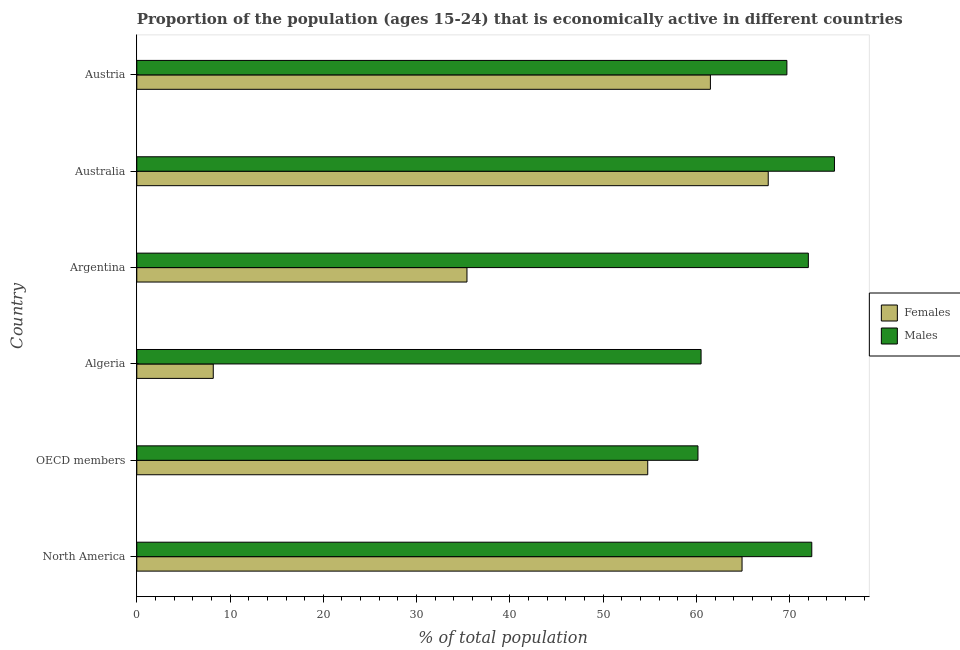How many different coloured bars are there?
Provide a succinct answer. 2. How many groups of bars are there?
Your answer should be very brief. 6. Are the number of bars per tick equal to the number of legend labels?
Provide a succinct answer. Yes. How many bars are there on the 5th tick from the bottom?
Provide a short and direct response. 2. What is the label of the 6th group of bars from the top?
Make the answer very short. North America. What is the percentage of economically active female population in OECD members?
Provide a short and direct response. 54.78. Across all countries, what is the maximum percentage of economically active male population?
Offer a very short reply. 74.8. Across all countries, what is the minimum percentage of economically active female population?
Give a very brief answer. 8.2. In which country was the percentage of economically active female population maximum?
Offer a very short reply. Australia. What is the total percentage of economically active male population in the graph?
Keep it short and to the point. 409.54. What is the difference between the percentage of economically active female population in Algeria and that in Austria?
Your answer should be compact. -53.3. What is the difference between the percentage of economically active male population in Australia and the percentage of economically active female population in OECD members?
Your answer should be compact. 20.02. What is the average percentage of economically active male population per country?
Keep it short and to the point. 68.26. What is the difference between the percentage of economically active male population and percentage of economically active female population in North America?
Ensure brevity in your answer.  7.48. What is the ratio of the percentage of economically active female population in Austria to that in North America?
Keep it short and to the point. 0.95. Is the difference between the percentage of economically active male population in Argentina and North America greater than the difference between the percentage of economically active female population in Argentina and North America?
Keep it short and to the point. Yes. What is the difference between the highest and the second highest percentage of economically active male population?
Provide a succinct answer. 2.43. What is the difference between the highest and the lowest percentage of economically active male population?
Your answer should be very brief. 14.63. Is the sum of the percentage of economically active male population in Algeria and OECD members greater than the maximum percentage of economically active female population across all countries?
Make the answer very short. Yes. What does the 1st bar from the top in Argentina represents?
Give a very brief answer. Males. What does the 1st bar from the bottom in North America represents?
Your response must be concise. Females. How many bars are there?
Keep it short and to the point. 12. Are all the bars in the graph horizontal?
Offer a terse response. Yes. Does the graph contain any zero values?
Offer a terse response. No. Does the graph contain grids?
Your answer should be compact. No. What is the title of the graph?
Provide a succinct answer. Proportion of the population (ages 15-24) that is economically active in different countries. What is the label or title of the X-axis?
Your answer should be very brief. % of total population. What is the % of total population of Females in North America?
Your response must be concise. 64.89. What is the % of total population of Males in North America?
Make the answer very short. 72.37. What is the % of total population of Females in OECD members?
Your answer should be compact. 54.78. What is the % of total population of Males in OECD members?
Provide a succinct answer. 60.17. What is the % of total population of Females in Algeria?
Your answer should be compact. 8.2. What is the % of total population in Males in Algeria?
Keep it short and to the point. 60.5. What is the % of total population in Females in Argentina?
Make the answer very short. 35.4. What is the % of total population of Females in Australia?
Ensure brevity in your answer.  67.7. What is the % of total population of Males in Australia?
Provide a succinct answer. 74.8. What is the % of total population of Females in Austria?
Your response must be concise. 61.5. What is the % of total population of Males in Austria?
Offer a terse response. 69.7. Across all countries, what is the maximum % of total population in Females?
Make the answer very short. 67.7. Across all countries, what is the maximum % of total population of Males?
Your answer should be compact. 74.8. Across all countries, what is the minimum % of total population of Females?
Your answer should be compact. 8.2. Across all countries, what is the minimum % of total population in Males?
Give a very brief answer. 60.17. What is the total % of total population in Females in the graph?
Provide a succinct answer. 292.47. What is the total % of total population in Males in the graph?
Offer a very short reply. 409.54. What is the difference between the % of total population of Females in North America and that in OECD members?
Ensure brevity in your answer.  10.11. What is the difference between the % of total population of Males in North America and that in OECD members?
Offer a terse response. 12.2. What is the difference between the % of total population in Females in North America and that in Algeria?
Give a very brief answer. 56.69. What is the difference between the % of total population in Males in North America and that in Algeria?
Ensure brevity in your answer.  11.87. What is the difference between the % of total population in Females in North America and that in Argentina?
Give a very brief answer. 29.49. What is the difference between the % of total population in Males in North America and that in Argentina?
Make the answer very short. 0.37. What is the difference between the % of total population of Females in North America and that in Australia?
Your answer should be compact. -2.81. What is the difference between the % of total population of Males in North America and that in Australia?
Your answer should be very brief. -2.43. What is the difference between the % of total population of Females in North America and that in Austria?
Your response must be concise. 3.39. What is the difference between the % of total population of Males in North America and that in Austria?
Provide a short and direct response. 2.67. What is the difference between the % of total population of Females in OECD members and that in Algeria?
Give a very brief answer. 46.58. What is the difference between the % of total population in Males in OECD members and that in Algeria?
Provide a succinct answer. -0.33. What is the difference between the % of total population of Females in OECD members and that in Argentina?
Ensure brevity in your answer.  19.38. What is the difference between the % of total population in Males in OECD members and that in Argentina?
Your answer should be very brief. -11.83. What is the difference between the % of total population of Females in OECD members and that in Australia?
Your answer should be very brief. -12.92. What is the difference between the % of total population in Males in OECD members and that in Australia?
Provide a short and direct response. -14.63. What is the difference between the % of total population in Females in OECD members and that in Austria?
Provide a succinct answer. -6.72. What is the difference between the % of total population of Males in OECD members and that in Austria?
Provide a short and direct response. -9.53. What is the difference between the % of total population in Females in Algeria and that in Argentina?
Your response must be concise. -27.2. What is the difference between the % of total population in Males in Algeria and that in Argentina?
Your response must be concise. -11.5. What is the difference between the % of total population in Females in Algeria and that in Australia?
Keep it short and to the point. -59.5. What is the difference between the % of total population in Males in Algeria and that in Australia?
Your response must be concise. -14.3. What is the difference between the % of total population in Females in Algeria and that in Austria?
Your answer should be very brief. -53.3. What is the difference between the % of total population in Males in Algeria and that in Austria?
Provide a short and direct response. -9.2. What is the difference between the % of total population in Females in Argentina and that in Australia?
Your response must be concise. -32.3. What is the difference between the % of total population of Males in Argentina and that in Australia?
Make the answer very short. -2.8. What is the difference between the % of total population of Females in Argentina and that in Austria?
Keep it short and to the point. -26.1. What is the difference between the % of total population of Males in Argentina and that in Austria?
Make the answer very short. 2.3. What is the difference between the % of total population in Females in North America and the % of total population in Males in OECD members?
Give a very brief answer. 4.73. What is the difference between the % of total population of Females in North America and the % of total population of Males in Algeria?
Your answer should be compact. 4.39. What is the difference between the % of total population of Females in North America and the % of total population of Males in Argentina?
Give a very brief answer. -7.11. What is the difference between the % of total population in Females in North America and the % of total population in Males in Australia?
Offer a terse response. -9.91. What is the difference between the % of total population of Females in North America and the % of total population of Males in Austria?
Provide a short and direct response. -4.81. What is the difference between the % of total population of Females in OECD members and the % of total population of Males in Algeria?
Ensure brevity in your answer.  -5.72. What is the difference between the % of total population in Females in OECD members and the % of total population in Males in Argentina?
Your answer should be very brief. -17.22. What is the difference between the % of total population of Females in OECD members and the % of total population of Males in Australia?
Keep it short and to the point. -20.02. What is the difference between the % of total population of Females in OECD members and the % of total population of Males in Austria?
Ensure brevity in your answer.  -14.92. What is the difference between the % of total population of Females in Algeria and the % of total population of Males in Argentina?
Your response must be concise. -63.8. What is the difference between the % of total population of Females in Algeria and the % of total population of Males in Australia?
Offer a very short reply. -66.6. What is the difference between the % of total population in Females in Algeria and the % of total population in Males in Austria?
Keep it short and to the point. -61.5. What is the difference between the % of total population in Females in Argentina and the % of total population in Males in Australia?
Ensure brevity in your answer.  -39.4. What is the difference between the % of total population of Females in Argentina and the % of total population of Males in Austria?
Offer a terse response. -34.3. What is the difference between the % of total population in Females in Australia and the % of total population in Males in Austria?
Provide a short and direct response. -2. What is the average % of total population in Females per country?
Offer a terse response. 48.75. What is the average % of total population of Males per country?
Your answer should be very brief. 68.26. What is the difference between the % of total population of Females and % of total population of Males in North America?
Your answer should be compact. -7.48. What is the difference between the % of total population of Females and % of total population of Males in OECD members?
Provide a short and direct response. -5.39. What is the difference between the % of total population in Females and % of total population in Males in Algeria?
Your answer should be very brief. -52.3. What is the difference between the % of total population of Females and % of total population of Males in Argentina?
Offer a very short reply. -36.6. What is the difference between the % of total population of Females and % of total population of Males in Australia?
Provide a succinct answer. -7.1. What is the ratio of the % of total population of Females in North America to that in OECD members?
Give a very brief answer. 1.18. What is the ratio of the % of total population in Males in North America to that in OECD members?
Your response must be concise. 1.2. What is the ratio of the % of total population in Females in North America to that in Algeria?
Ensure brevity in your answer.  7.91. What is the ratio of the % of total population of Males in North America to that in Algeria?
Provide a short and direct response. 1.2. What is the ratio of the % of total population of Females in North America to that in Argentina?
Your answer should be compact. 1.83. What is the ratio of the % of total population of Females in North America to that in Australia?
Offer a very short reply. 0.96. What is the ratio of the % of total population in Males in North America to that in Australia?
Your answer should be very brief. 0.97. What is the ratio of the % of total population of Females in North America to that in Austria?
Ensure brevity in your answer.  1.06. What is the ratio of the % of total population in Males in North America to that in Austria?
Provide a short and direct response. 1.04. What is the ratio of the % of total population in Females in OECD members to that in Algeria?
Make the answer very short. 6.68. What is the ratio of the % of total population in Males in OECD members to that in Algeria?
Provide a short and direct response. 0.99. What is the ratio of the % of total population of Females in OECD members to that in Argentina?
Provide a succinct answer. 1.55. What is the ratio of the % of total population in Males in OECD members to that in Argentina?
Your answer should be compact. 0.84. What is the ratio of the % of total population in Females in OECD members to that in Australia?
Offer a terse response. 0.81. What is the ratio of the % of total population in Males in OECD members to that in Australia?
Provide a short and direct response. 0.8. What is the ratio of the % of total population of Females in OECD members to that in Austria?
Ensure brevity in your answer.  0.89. What is the ratio of the % of total population of Males in OECD members to that in Austria?
Keep it short and to the point. 0.86. What is the ratio of the % of total population of Females in Algeria to that in Argentina?
Provide a succinct answer. 0.23. What is the ratio of the % of total population in Males in Algeria to that in Argentina?
Ensure brevity in your answer.  0.84. What is the ratio of the % of total population in Females in Algeria to that in Australia?
Your answer should be compact. 0.12. What is the ratio of the % of total population of Males in Algeria to that in Australia?
Your response must be concise. 0.81. What is the ratio of the % of total population of Females in Algeria to that in Austria?
Make the answer very short. 0.13. What is the ratio of the % of total population in Males in Algeria to that in Austria?
Ensure brevity in your answer.  0.87. What is the ratio of the % of total population in Females in Argentina to that in Australia?
Your response must be concise. 0.52. What is the ratio of the % of total population of Males in Argentina to that in Australia?
Your answer should be compact. 0.96. What is the ratio of the % of total population of Females in Argentina to that in Austria?
Your answer should be very brief. 0.58. What is the ratio of the % of total population in Males in Argentina to that in Austria?
Provide a succinct answer. 1.03. What is the ratio of the % of total population of Females in Australia to that in Austria?
Keep it short and to the point. 1.1. What is the ratio of the % of total population of Males in Australia to that in Austria?
Provide a succinct answer. 1.07. What is the difference between the highest and the second highest % of total population of Females?
Give a very brief answer. 2.81. What is the difference between the highest and the second highest % of total population of Males?
Provide a succinct answer. 2.43. What is the difference between the highest and the lowest % of total population in Females?
Provide a short and direct response. 59.5. What is the difference between the highest and the lowest % of total population of Males?
Make the answer very short. 14.63. 